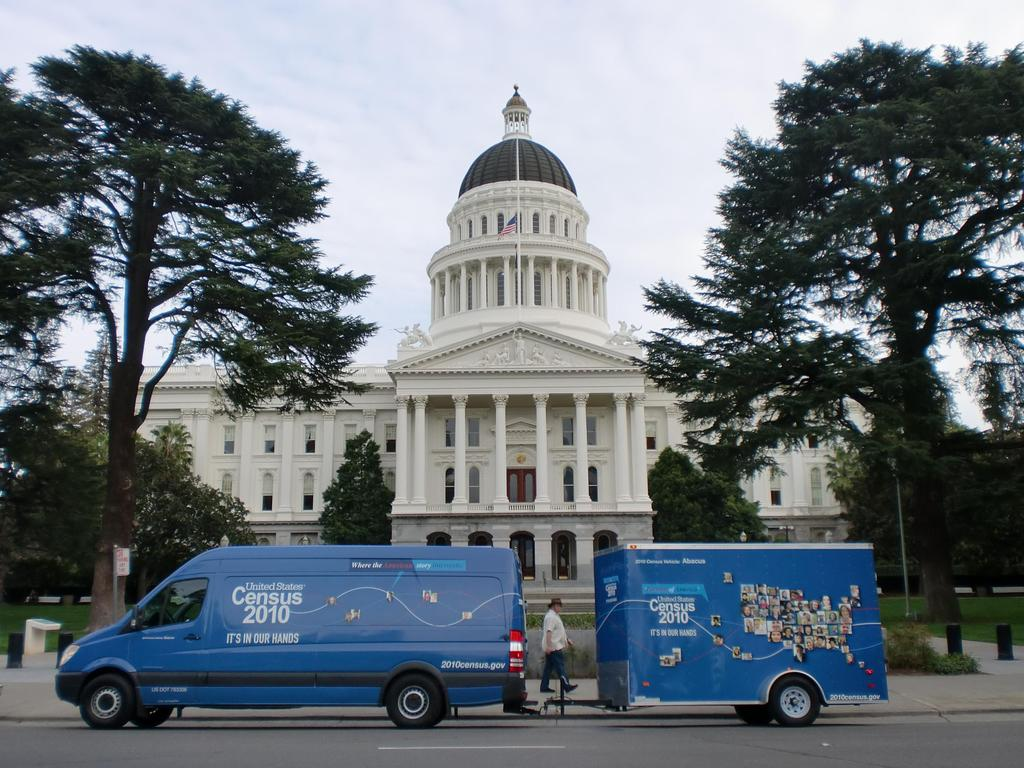What type of structure is present in the image? There is a building in the image. What else can be seen near the building? There are two vehicles and a person in front of the building. What can be seen in the background of the image? There are trees visible in the image. Where is the goldfish swimming in the image? There is no goldfish present in the image. 